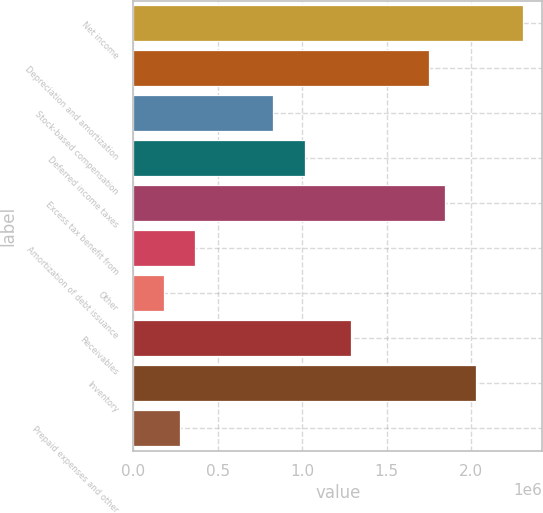Convert chart to OTSL. <chart><loc_0><loc_0><loc_500><loc_500><bar_chart><fcel>Net income<fcel>Depreciation and amortization<fcel>Stock-based compensation<fcel>Deferred income taxes<fcel>Excess tax benefit from<fcel>Amortization of debt issuance<fcel>Other<fcel>Receivables<fcel>Inventory<fcel>Prepaid expenses and other<nl><fcel>2.30402e+06<fcel>1.75107e+06<fcel>829469<fcel>1.01379e+06<fcel>1.84322e+06<fcel>368671<fcel>184352<fcel>1.29027e+06<fcel>2.02754e+06<fcel>276512<nl></chart> 